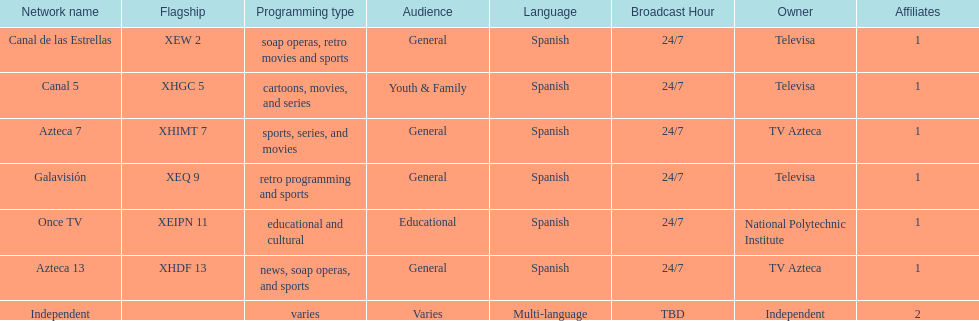What is the number of networks that are owned by televisa? 3. 